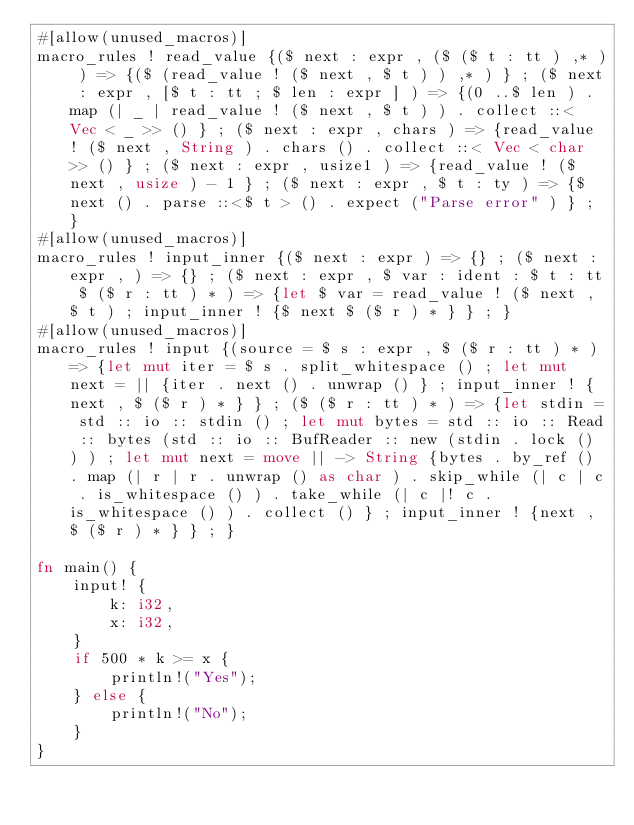Convert code to text. <code><loc_0><loc_0><loc_500><loc_500><_Rust_>#[allow(unused_macros)]
macro_rules ! read_value {($ next : expr , ($ ($ t : tt ) ,* ) ) => {($ (read_value ! ($ next , $ t ) ) ,* ) } ; ($ next : expr , [$ t : tt ; $ len : expr ] ) => {(0 ..$ len ) . map (| _ | read_value ! ($ next , $ t ) ) . collect ::< Vec < _ >> () } ; ($ next : expr , chars ) => {read_value ! ($ next , String ) . chars () . collect ::< Vec < char >> () } ; ($ next : expr , usize1 ) => {read_value ! ($ next , usize ) - 1 } ; ($ next : expr , $ t : ty ) => {$ next () . parse ::<$ t > () . expect ("Parse error" ) } ; }
#[allow(unused_macros)]
macro_rules ! input_inner {($ next : expr ) => {} ; ($ next : expr , ) => {} ; ($ next : expr , $ var : ident : $ t : tt $ ($ r : tt ) * ) => {let $ var = read_value ! ($ next , $ t ) ; input_inner ! {$ next $ ($ r ) * } } ; }
#[allow(unused_macros)]
macro_rules ! input {(source = $ s : expr , $ ($ r : tt ) * ) => {let mut iter = $ s . split_whitespace () ; let mut next = || {iter . next () . unwrap () } ; input_inner ! {next , $ ($ r ) * } } ; ($ ($ r : tt ) * ) => {let stdin = std :: io :: stdin () ; let mut bytes = std :: io :: Read :: bytes (std :: io :: BufReader :: new (stdin . lock () ) ) ; let mut next = move || -> String {bytes . by_ref () . map (| r | r . unwrap () as char ) . skip_while (| c | c . is_whitespace () ) . take_while (| c |! c . is_whitespace () ) . collect () } ; input_inner ! {next , $ ($ r ) * } } ; }

fn main() {
    input! {
        k: i32,
        x: i32,
    }
    if 500 * k >= x {
        println!("Yes");
    } else {
        println!("No");
    }
}
</code> 